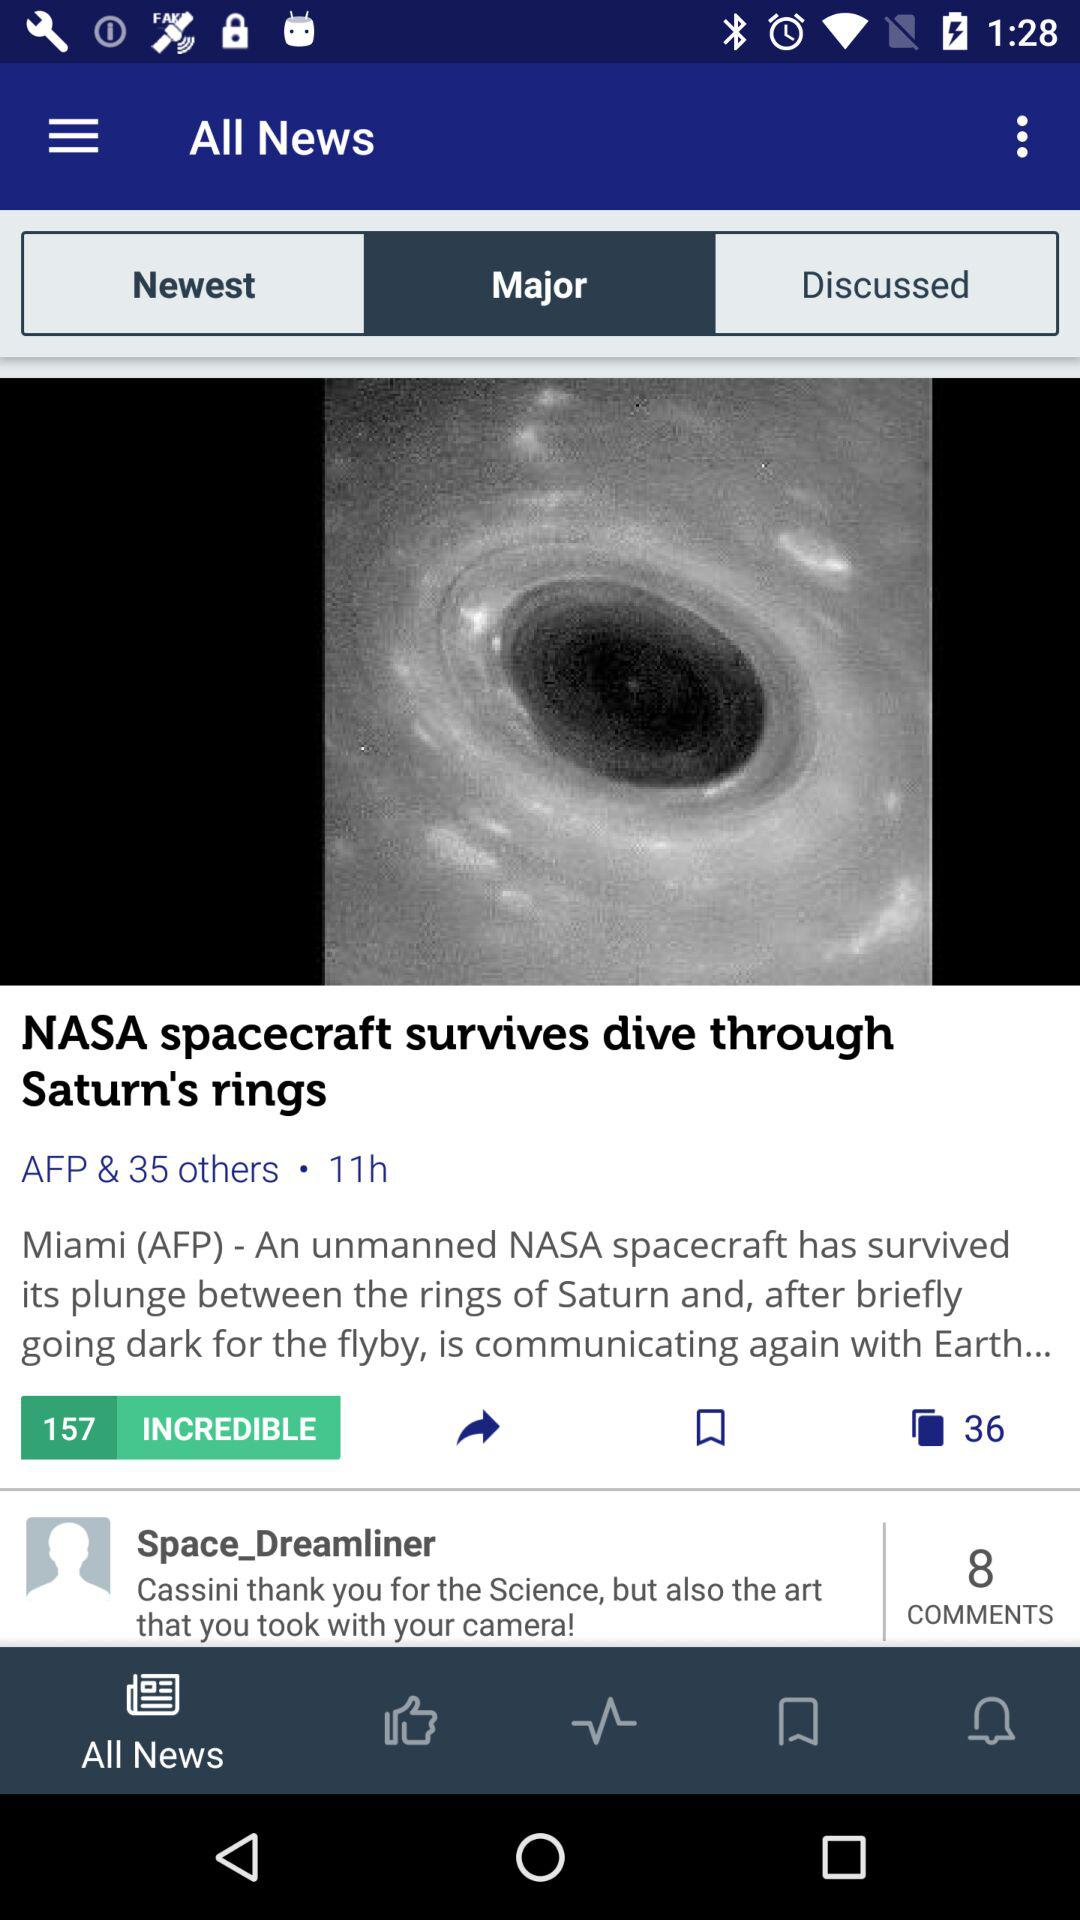How many comments are there? There are 8 comments. 